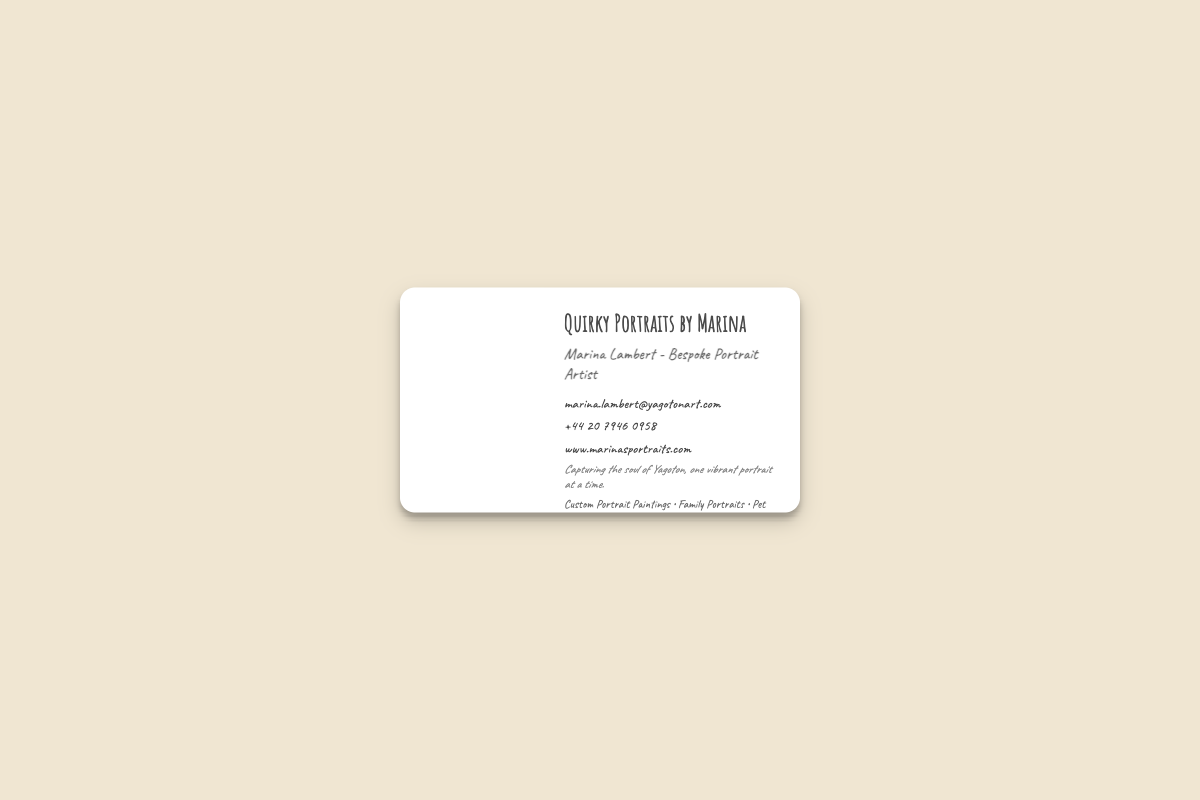what is the artist's name? The artist's name is listed prominently at the top of the business card as "Marina Lambert".
Answer: Marina Lambert what is the primary service offered? The primary service offered is bespoke portrait painting, as indicated by the title on the card.
Answer: Bespoke Portrait Artist what is the contact email? The contact email is provided in the document for inquiries.
Answer: marina.lambert@yagotonart.com what is the phone number listed? The business card includes a phone number where the artist can be contacted.
Answer: +44 20 7946 0958 what is the address of the studio? The address for the studio is specified on the card.
Answer: 24 Yagoton Lane, Yagoton, London, UK what types of portraits are offered? The card lists the types of portraits available as part of the services offered.
Answer: Custom Portrait Paintings • Family Portraits • Pet Portraits • Special Occasion Portraits how is the essence of Yagoton described? The tagline on the business card conveys the essence of Yagoton in the artist's work.
Answer: Capturing the soul of Yagoton, one vibrant portrait at a time what social media is mentioned? The document provides links to the artist's social media accounts, indicating where to find more of their work.
Answer: @marinas_art, fb.me/marinasart what is the background image of the left side? The left side of the card features an image related to the artist's theme.
Answer: Yagoton street scene miniaturized 